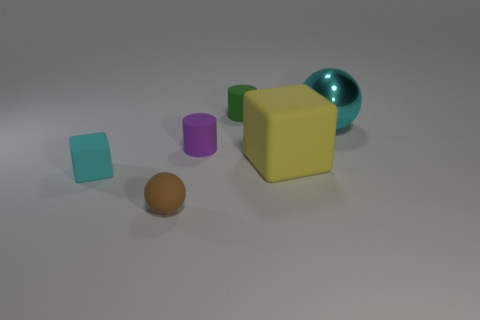Are there any other things that are made of the same material as the cyan ball?
Your response must be concise. No. What material is the big cyan ball?
Provide a succinct answer. Metal. What size is the matte thing that is behind the yellow matte block and in front of the green cylinder?
Provide a succinct answer. Small. There is a large thing that is the same color as the small block; what material is it?
Offer a very short reply. Metal. What number of brown things are there?
Give a very brief answer. 1. Is the number of matte cylinders less than the number of rubber objects?
Make the answer very short. Yes. There is a sphere that is the same size as the yellow matte object; what is it made of?
Give a very brief answer. Metal. What number of things are large yellow metallic objects or small matte cubes?
Make the answer very short. 1. How many matte objects are in front of the green thing and behind the brown matte sphere?
Keep it short and to the point. 3. Are there fewer large things that are in front of the small green rubber thing than small things?
Offer a terse response. Yes. 